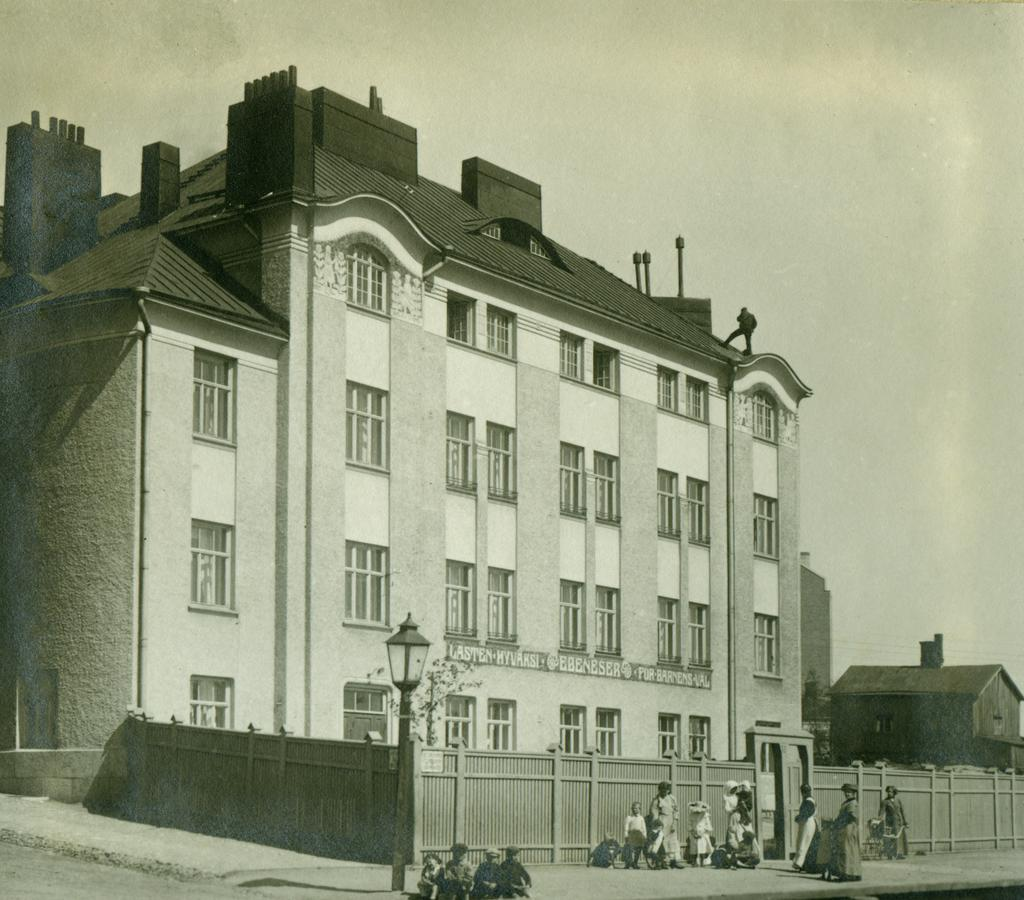What is the color scheme of the image? The image is black and white. What is the main subject in the middle of the image? There is a building in the middle of the image. What is the source of light in the image? There is light in the middle of the image. Who or what can be seen at the bottom of the image? There are people at the bottom of the image. What is visible at the top of the image? The sky is visible at the top of the image. What type of ant can be seen performing an operation on the building in the image? There are no ants or operations present in the image; it features a building with light and people. What type of quartz is visible in the sky at the top of the image? There is no quartz visible in the sky at the top of the image; it is simply the sky. 